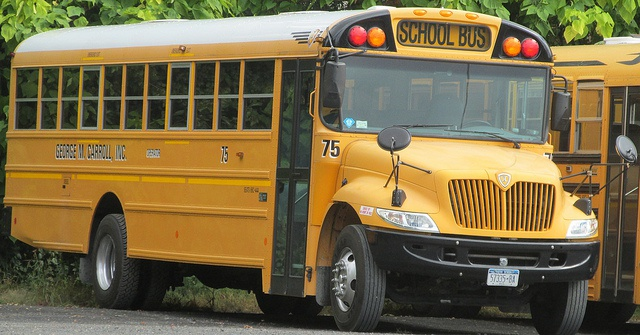Describe the objects in this image and their specific colors. I can see bus in darkgreen, black, olive, gray, and orange tones and bus in darkgreen, black, olive, and gray tones in this image. 